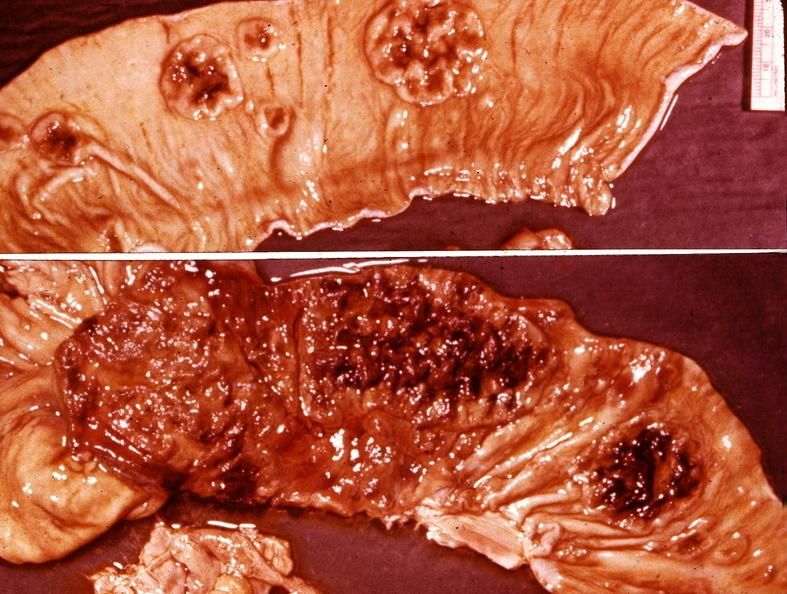does this image show small intestine, typhoid?
Answer the question using a single word or phrase. Yes 